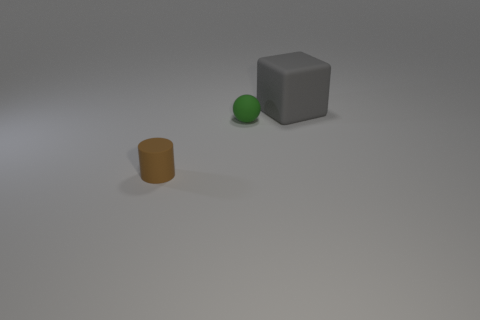Add 3 green things. How many objects exist? 6 Subtract all cylinders. How many objects are left? 2 Subtract all small brown balls. Subtract all tiny rubber things. How many objects are left? 1 Add 1 small green matte spheres. How many small green matte spheres are left? 2 Add 3 cubes. How many cubes exist? 4 Subtract 0 cyan balls. How many objects are left? 3 